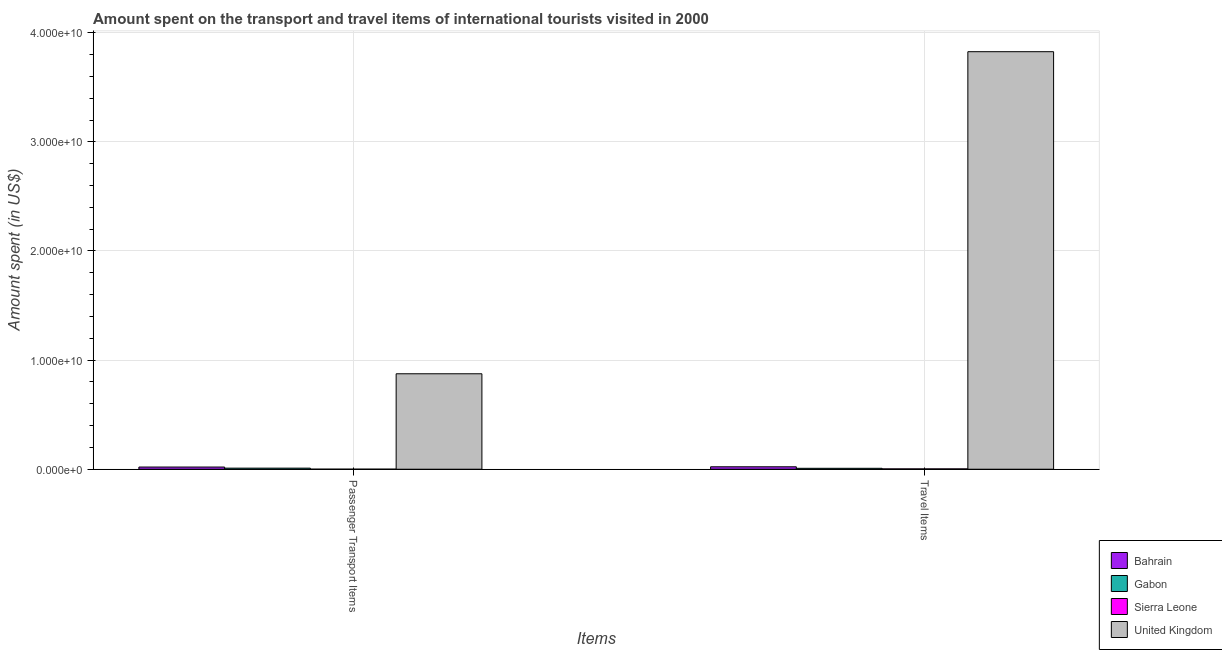Are the number of bars per tick equal to the number of legend labels?
Your answer should be very brief. Yes. Are the number of bars on each tick of the X-axis equal?
Your response must be concise. Yes. How many bars are there on the 1st tick from the right?
Your answer should be compact. 4. What is the label of the 2nd group of bars from the left?
Your answer should be compact. Travel Items. What is the amount spent on passenger transport items in United Kingdom?
Make the answer very short. 8.75e+09. Across all countries, what is the maximum amount spent in travel items?
Make the answer very short. 3.83e+1. Across all countries, what is the minimum amount spent in travel items?
Offer a terse response. 3.20e+07. In which country was the amount spent in travel items maximum?
Provide a succinct answer. United Kingdom. In which country was the amount spent on passenger transport items minimum?
Provide a short and direct response. Sierra Leone. What is the total amount spent in travel items in the graph?
Your answer should be very brief. 3.86e+1. What is the difference between the amount spent in travel items in Sierra Leone and that in United Kingdom?
Provide a short and direct response. -3.82e+1. What is the difference between the amount spent in travel items in Bahrain and the amount spent on passenger transport items in Gabon?
Your response must be concise. 1.25e+08. What is the average amount spent in travel items per country?
Ensure brevity in your answer.  9.65e+09. What is the difference between the amount spent in travel items and amount spent on passenger transport items in Bahrain?
Offer a terse response. 2.30e+07. What is the ratio of the amount spent in travel items in Bahrain to that in Gabon?
Provide a short and direct response. 2.67. What does the 1st bar from the left in Passenger Transport Items represents?
Provide a succinct answer. Bahrain. What does the 4th bar from the right in Passenger Transport Items represents?
Provide a succinct answer. Bahrain. How many bars are there?
Your answer should be very brief. 8. What is the difference between two consecutive major ticks on the Y-axis?
Your answer should be compact. 1.00e+1. Does the graph contain grids?
Give a very brief answer. Yes. How many legend labels are there?
Give a very brief answer. 4. How are the legend labels stacked?
Give a very brief answer. Vertical. What is the title of the graph?
Provide a short and direct response. Amount spent on the transport and travel items of international tourists visited in 2000. Does "Algeria" appear as one of the legend labels in the graph?
Provide a short and direct response. No. What is the label or title of the X-axis?
Keep it short and to the point. Items. What is the label or title of the Y-axis?
Your response must be concise. Amount spent (in US$). What is the Amount spent (in US$) of Bahrain in Passenger Transport Items?
Offer a terse response. 2.01e+08. What is the Amount spent (in US$) of Gabon in Passenger Transport Items?
Your answer should be compact. 9.90e+07. What is the Amount spent (in US$) of Sierra Leone in Passenger Transport Items?
Provide a short and direct response. 2.50e+06. What is the Amount spent (in US$) in United Kingdom in Passenger Transport Items?
Ensure brevity in your answer.  8.75e+09. What is the Amount spent (in US$) in Bahrain in Travel Items?
Your response must be concise. 2.24e+08. What is the Amount spent (in US$) in Gabon in Travel Items?
Offer a terse response. 8.40e+07. What is the Amount spent (in US$) in Sierra Leone in Travel Items?
Provide a short and direct response. 3.20e+07. What is the Amount spent (in US$) of United Kingdom in Travel Items?
Provide a short and direct response. 3.83e+1. Across all Items, what is the maximum Amount spent (in US$) of Bahrain?
Offer a terse response. 2.24e+08. Across all Items, what is the maximum Amount spent (in US$) in Gabon?
Offer a very short reply. 9.90e+07. Across all Items, what is the maximum Amount spent (in US$) in Sierra Leone?
Give a very brief answer. 3.20e+07. Across all Items, what is the maximum Amount spent (in US$) of United Kingdom?
Make the answer very short. 3.83e+1. Across all Items, what is the minimum Amount spent (in US$) of Bahrain?
Provide a short and direct response. 2.01e+08. Across all Items, what is the minimum Amount spent (in US$) in Gabon?
Offer a very short reply. 8.40e+07. Across all Items, what is the minimum Amount spent (in US$) of Sierra Leone?
Give a very brief answer. 2.50e+06. Across all Items, what is the minimum Amount spent (in US$) of United Kingdom?
Keep it short and to the point. 8.75e+09. What is the total Amount spent (in US$) in Bahrain in the graph?
Your response must be concise. 4.25e+08. What is the total Amount spent (in US$) of Gabon in the graph?
Offer a very short reply. 1.83e+08. What is the total Amount spent (in US$) of Sierra Leone in the graph?
Make the answer very short. 3.45e+07. What is the total Amount spent (in US$) in United Kingdom in the graph?
Offer a very short reply. 4.70e+1. What is the difference between the Amount spent (in US$) of Bahrain in Passenger Transport Items and that in Travel Items?
Offer a very short reply. -2.30e+07. What is the difference between the Amount spent (in US$) of Gabon in Passenger Transport Items and that in Travel Items?
Offer a very short reply. 1.50e+07. What is the difference between the Amount spent (in US$) in Sierra Leone in Passenger Transport Items and that in Travel Items?
Make the answer very short. -2.95e+07. What is the difference between the Amount spent (in US$) of United Kingdom in Passenger Transport Items and that in Travel Items?
Your answer should be compact. -2.95e+1. What is the difference between the Amount spent (in US$) in Bahrain in Passenger Transport Items and the Amount spent (in US$) in Gabon in Travel Items?
Offer a very short reply. 1.17e+08. What is the difference between the Amount spent (in US$) in Bahrain in Passenger Transport Items and the Amount spent (in US$) in Sierra Leone in Travel Items?
Provide a short and direct response. 1.69e+08. What is the difference between the Amount spent (in US$) of Bahrain in Passenger Transport Items and the Amount spent (in US$) of United Kingdom in Travel Items?
Your answer should be compact. -3.81e+1. What is the difference between the Amount spent (in US$) in Gabon in Passenger Transport Items and the Amount spent (in US$) in Sierra Leone in Travel Items?
Your answer should be very brief. 6.70e+07. What is the difference between the Amount spent (in US$) of Gabon in Passenger Transport Items and the Amount spent (in US$) of United Kingdom in Travel Items?
Keep it short and to the point. -3.82e+1. What is the difference between the Amount spent (in US$) in Sierra Leone in Passenger Transport Items and the Amount spent (in US$) in United Kingdom in Travel Items?
Your answer should be compact. -3.83e+1. What is the average Amount spent (in US$) of Bahrain per Items?
Your response must be concise. 2.12e+08. What is the average Amount spent (in US$) in Gabon per Items?
Keep it short and to the point. 9.15e+07. What is the average Amount spent (in US$) of Sierra Leone per Items?
Ensure brevity in your answer.  1.72e+07. What is the average Amount spent (in US$) of United Kingdom per Items?
Your answer should be compact. 2.35e+1. What is the difference between the Amount spent (in US$) of Bahrain and Amount spent (in US$) of Gabon in Passenger Transport Items?
Your response must be concise. 1.02e+08. What is the difference between the Amount spent (in US$) in Bahrain and Amount spent (in US$) in Sierra Leone in Passenger Transport Items?
Keep it short and to the point. 1.98e+08. What is the difference between the Amount spent (in US$) in Bahrain and Amount spent (in US$) in United Kingdom in Passenger Transport Items?
Provide a short and direct response. -8.55e+09. What is the difference between the Amount spent (in US$) of Gabon and Amount spent (in US$) of Sierra Leone in Passenger Transport Items?
Your response must be concise. 9.65e+07. What is the difference between the Amount spent (in US$) in Gabon and Amount spent (in US$) in United Kingdom in Passenger Transport Items?
Offer a terse response. -8.65e+09. What is the difference between the Amount spent (in US$) of Sierra Leone and Amount spent (in US$) of United Kingdom in Passenger Transport Items?
Make the answer very short. -8.74e+09. What is the difference between the Amount spent (in US$) in Bahrain and Amount spent (in US$) in Gabon in Travel Items?
Offer a terse response. 1.40e+08. What is the difference between the Amount spent (in US$) in Bahrain and Amount spent (in US$) in Sierra Leone in Travel Items?
Offer a terse response. 1.92e+08. What is the difference between the Amount spent (in US$) of Bahrain and Amount spent (in US$) of United Kingdom in Travel Items?
Make the answer very short. -3.80e+1. What is the difference between the Amount spent (in US$) in Gabon and Amount spent (in US$) in Sierra Leone in Travel Items?
Provide a succinct answer. 5.20e+07. What is the difference between the Amount spent (in US$) of Gabon and Amount spent (in US$) of United Kingdom in Travel Items?
Give a very brief answer. -3.82e+1. What is the difference between the Amount spent (in US$) in Sierra Leone and Amount spent (in US$) in United Kingdom in Travel Items?
Offer a terse response. -3.82e+1. What is the ratio of the Amount spent (in US$) of Bahrain in Passenger Transport Items to that in Travel Items?
Provide a succinct answer. 0.9. What is the ratio of the Amount spent (in US$) in Gabon in Passenger Transport Items to that in Travel Items?
Offer a terse response. 1.18. What is the ratio of the Amount spent (in US$) of Sierra Leone in Passenger Transport Items to that in Travel Items?
Your answer should be very brief. 0.08. What is the ratio of the Amount spent (in US$) of United Kingdom in Passenger Transport Items to that in Travel Items?
Offer a very short reply. 0.23. What is the difference between the highest and the second highest Amount spent (in US$) in Bahrain?
Give a very brief answer. 2.30e+07. What is the difference between the highest and the second highest Amount spent (in US$) in Gabon?
Keep it short and to the point. 1.50e+07. What is the difference between the highest and the second highest Amount spent (in US$) of Sierra Leone?
Give a very brief answer. 2.95e+07. What is the difference between the highest and the second highest Amount spent (in US$) in United Kingdom?
Keep it short and to the point. 2.95e+1. What is the difference between the highest and the lowest Amount spent (in US$) of Bahrain?
Make the answer very short. 2.30e+07. What is the difference between the highest and the lowest Amount spent (in US$) in Gabon?
Ensure brevity in your answer.  1.50e+07. What is the difference between the highest and the lowest Amount spent (in US$) of Sierra Leone?
Give a very brief answer. 2.95e+07. What is the difference between the highest and the lowest Amount spent (in US$) of United Kingdom?
Ensure brevity in your answer.  2.95e+1. 